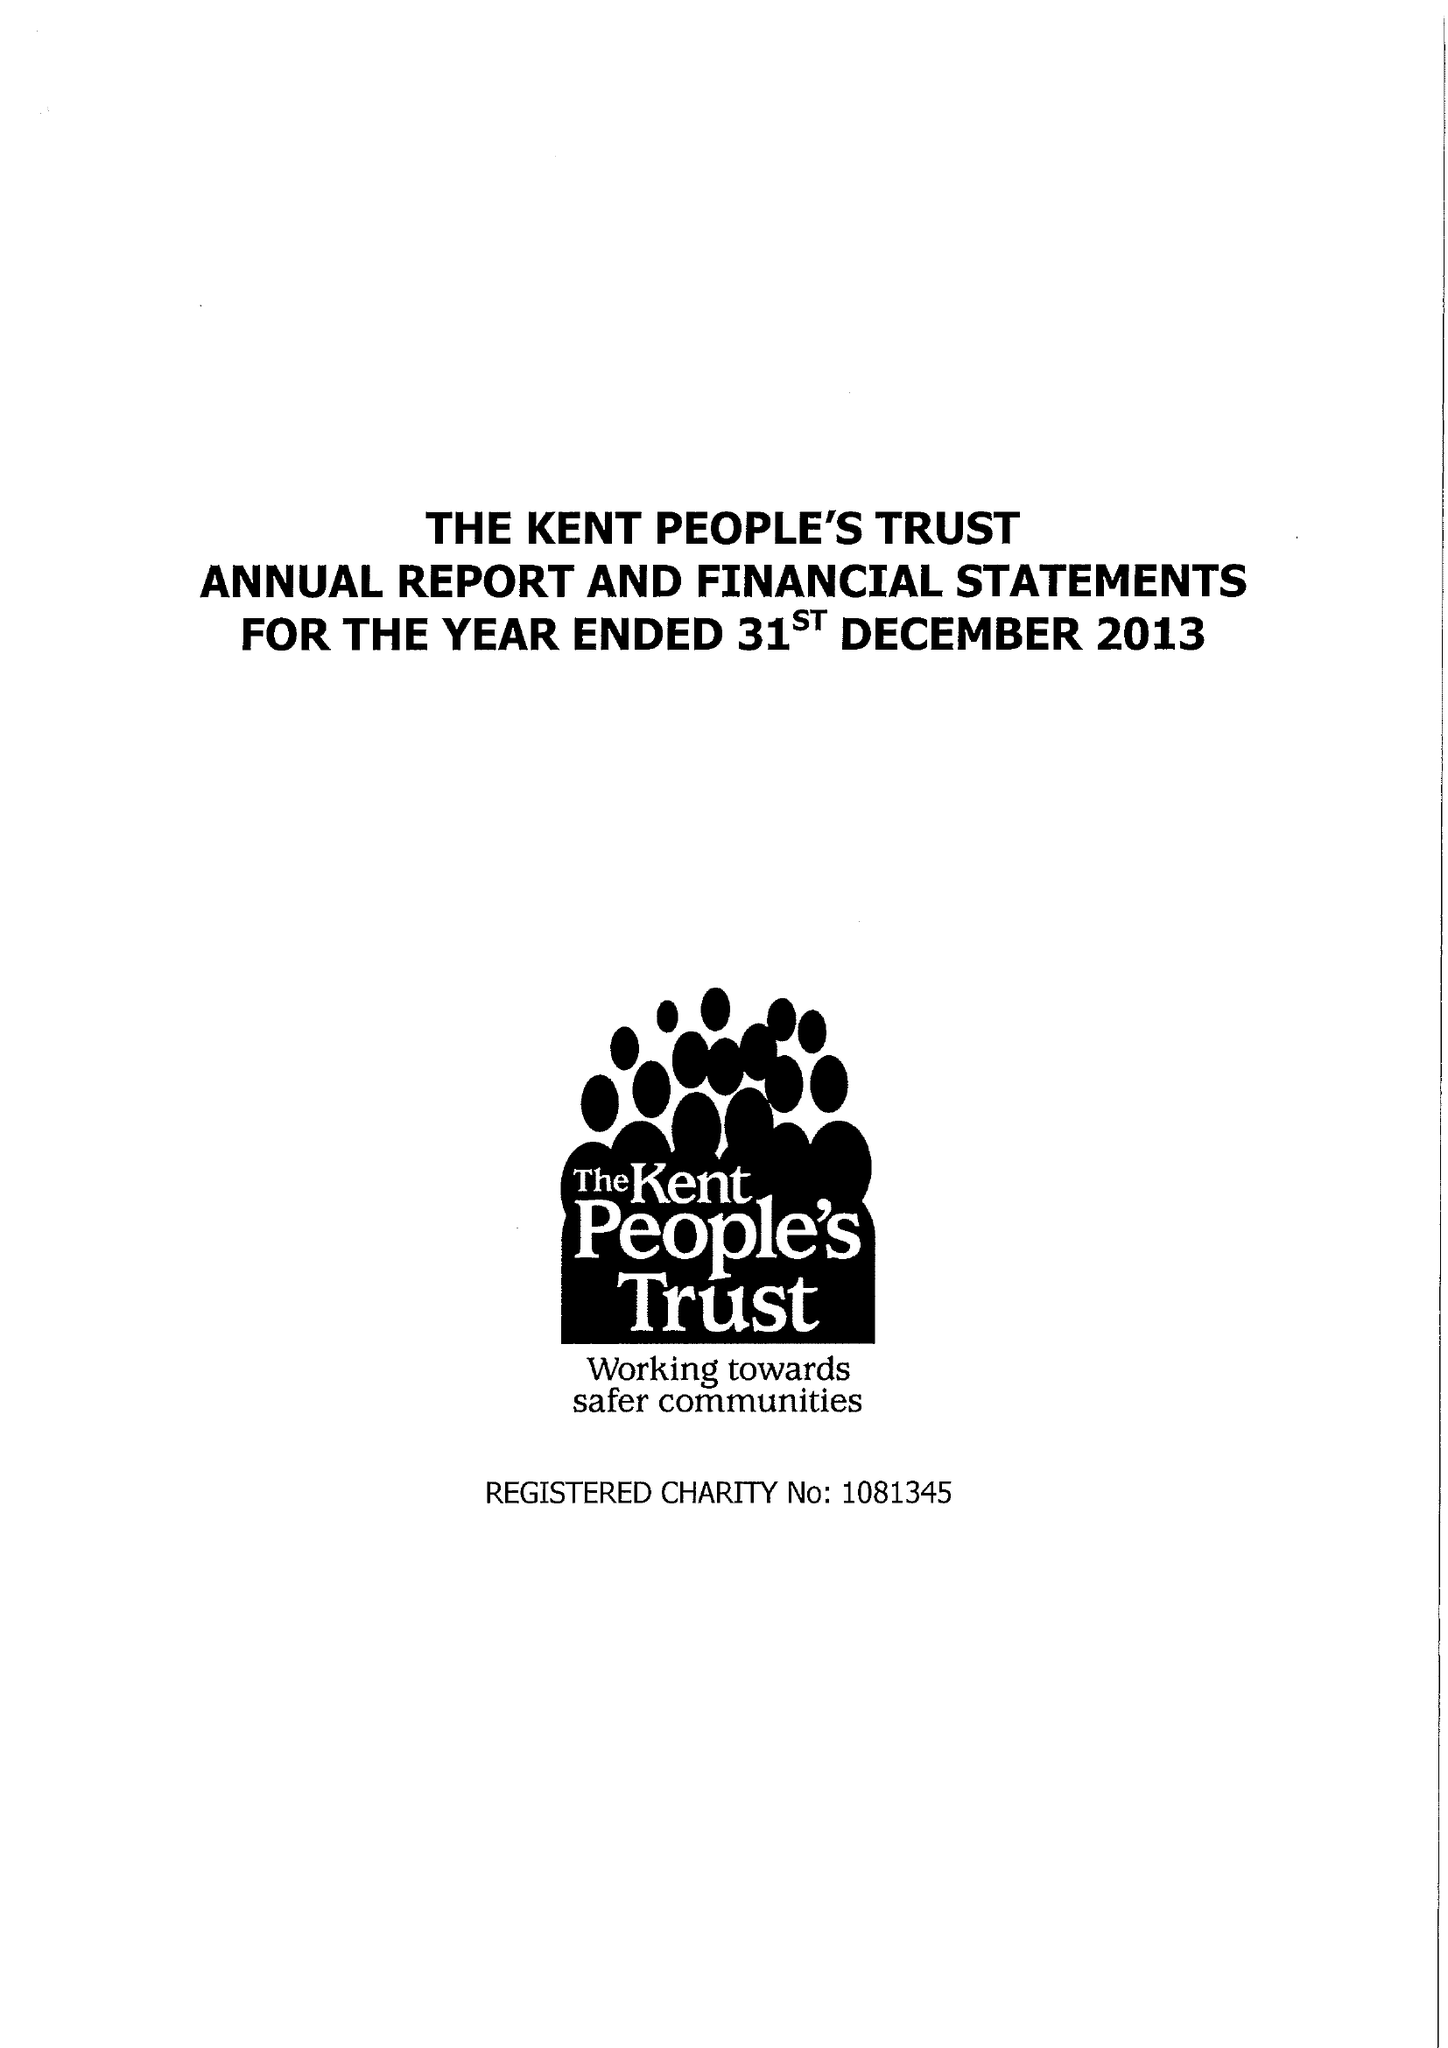What is the value for the address__post_town?
Answer the question using a single word or phrase. MAIDSTONE 